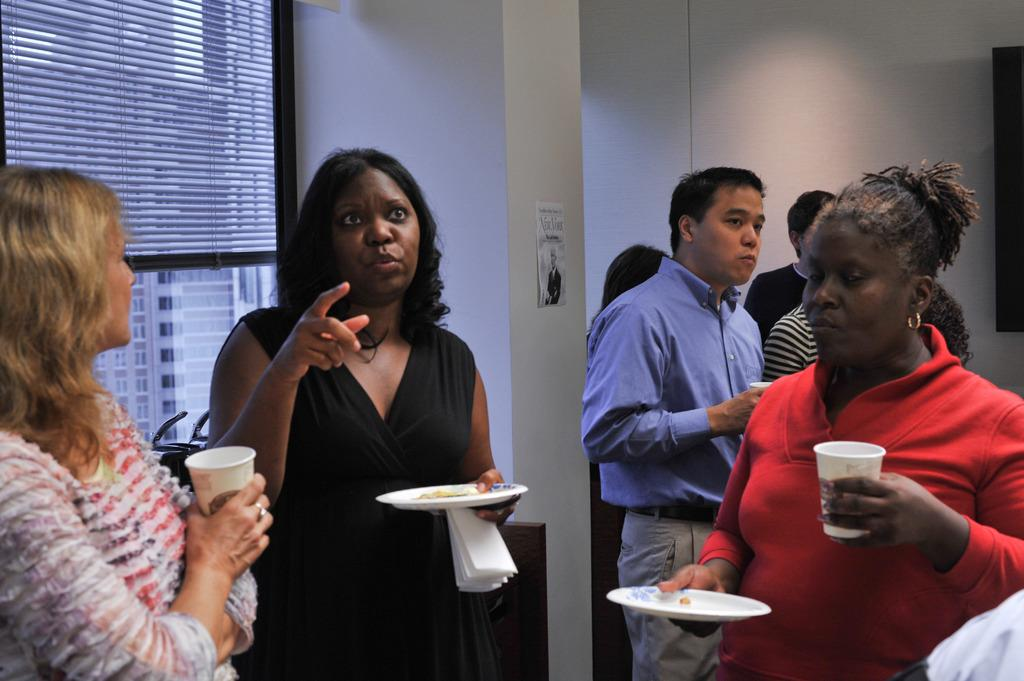What are the people in the image doing? The groups of people are standing in the image. What structure can be seen in the image? There is a pillar in the image. What is attached to the pillar? There is a poster attached to the pillar. What architectural feature is visible in the image? There is a window in the image. What is associated with the window? There is a plastic roller blind associated with the window. What time is displayed on the clock in the image? There is no clock present in the image. How does the plastic roller blind help the people in the image? The plastic roller blind is not associated with helping the people in the image; it is simply a window covering. 